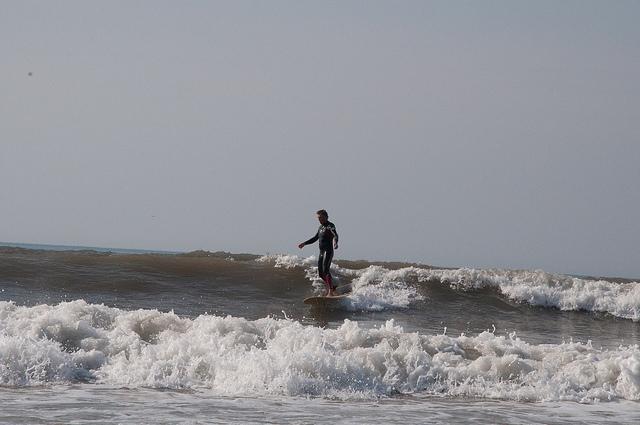Is this day or night?
Be succinct. Day. What is the man doing?
Be succinct. Surfing. Are the waves foamy?
Answer briefly. Yes. 